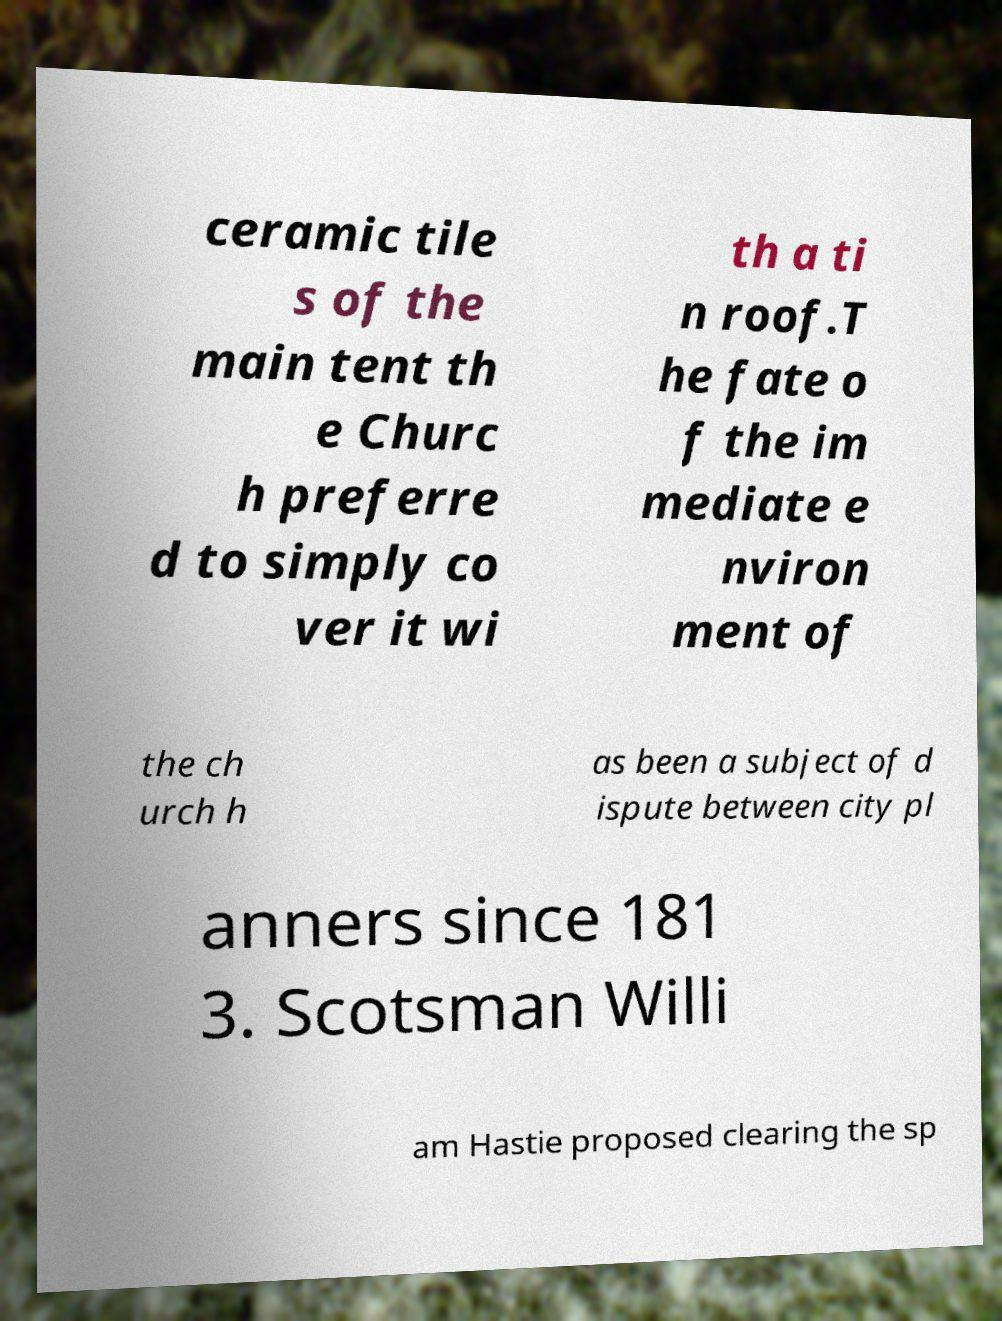For documentation purposes, I need the text within this image transcribed. Could you provide that? ceramic tile s of the main tent th e Churc h preferre d to simply co ver it wi th a ti n roof.T he fate o f the im mediate e nviron ment of the ch urch h as been a subject of d ispute between city pl anners since 181 3. Scotsman Willi am Hastie proposed clearing the sp 